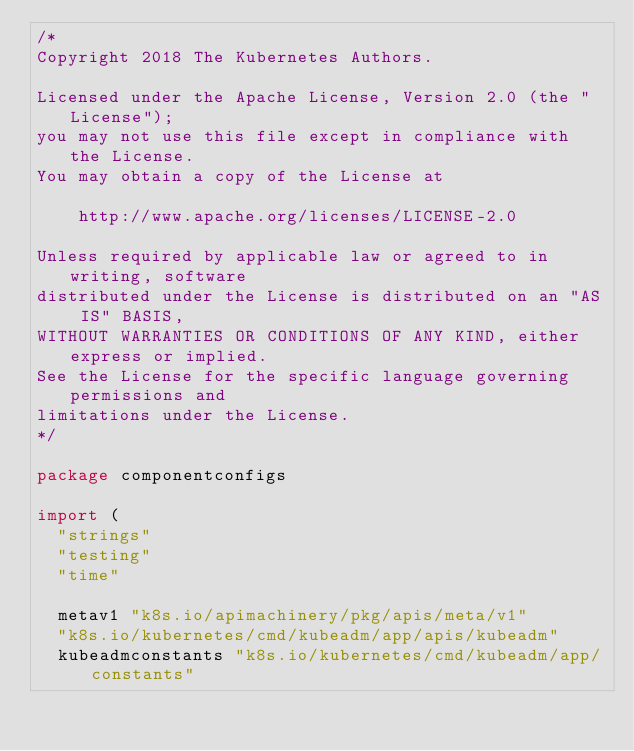<code> <loc_0><loc_0><loc_500><loc_500><_Go_>/*
Copyright 2018 The Kubernetes Authors.

Licensed under the Apache License, Version 2.0 (the "License");
you may not use this file except in compliance with the License.
You may obtain a copy of the License at

    http://www.apache.org/licenses/LICENSE-2.0

Unless required by applicable law or agreed to in writing, software
distributed under the License is distributed on an "AS IS" BASIS,
WITHOUT WARRANTIES OR CONDITIONS OF ANY KIND, either express or implied.
See the License for the specific language governing permissions and
limitations under the License.
*/

package componentconfigs

import (
	"strings"
	"testing"
	"time"

	metav1 "k8s.io/apimachinery/pkg/apis/meta/v1"
	"k8s.io/kubernetes/cmd/kubeadm/app/apis/kubeadm"
	kubeadmconstants "k8s.io/kubernetes/cmd/kubeadm/app/constants"</code> 